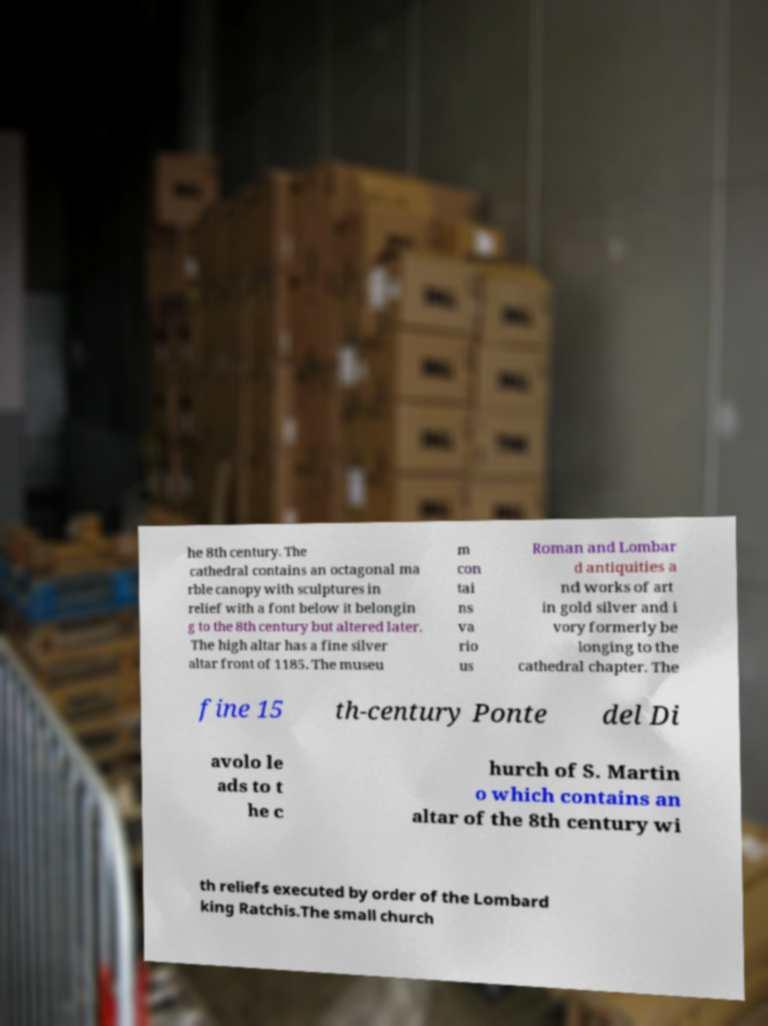Could you extract and type out the text from this image? he 8th century. The cathedral contains an octagonal ma rble canopy with sculptures in relief with a font below it belongin g to the 8th century but altered later. The high altar has a fine silver altar front of 1185. The museu m con tai ns va rio us Roman and Lombar d antiquities a nd works of art in gold silver and i vory formerly be longing to the cathedral chapter. The fine 15 th-century Ponte del Di avolo le ads to t he c hurch of S. Martin o which contains an altar of the 8th century wi th reliefs executed by order of the Lombard king Ratchis.The small church 